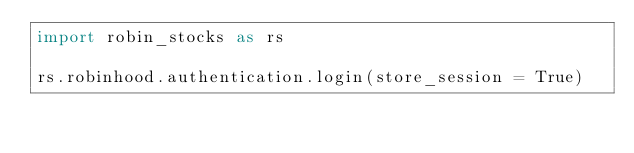<code> <loc_0><loc_0><loc_500><loc_500><_Python_>import robin_stocks as rs

rs.robinhood.authentication.login(store_session = True)

</code> 